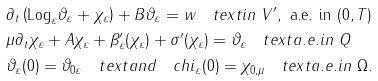Convert formula to latex. <formula><loc_0><loc_0><loc_500><loc_500>& \partial _ { t } \left ( \text {Log} _ { \varepsilon } \vartheta _ { \varepsilon } + \chi _ { \varepsilon } \right ) + B \vartheta _ { \varepsilon } = w \quad t e x t { i n } \ V ^ { \prime } , \ \text {a.e. in} \ ( 0 , T ) \\ & \mu \partial _ { t } \chi _ { \varepsilon } + A \chi _ { \varepsilon } + \beta ^ { \prime } _ { \varepsilon } ( \chi _ { \varepsilon } ) + \sigma ^ { \prime } ( \chi _ { \varepsilon } ) = \vartheta _ { \varepsilon } \quad t e x t { a . e . i n } \ Q \\ & \vartheta _ { \varepsilon } ( 0 ) = \vartheta _ { 0 \varepsilon } \quad t e x t { a n d } \quad c h i _ { \varepsilon } ( 0 ) = \chi _ { 0 , \mu } \quad t e x t { a . e . i n } \ \Omega .</formula> 